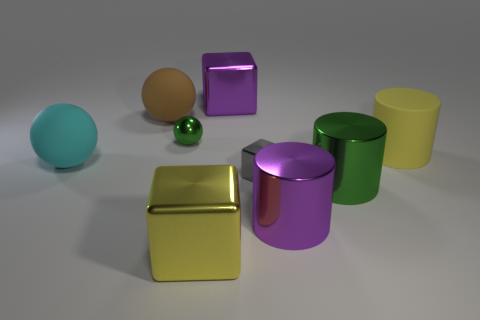What shape is the metal thing that is the same color as the small sphere?
Offer a terse response. Cylinder. What number of metallic things have the same color as the big matte cylinder?
Offer a terse response. 1. What is the size of the gray metallic block?
Provide a succinct answer. Small. There is a gray object; does it have the same size as the purple metallic object that is behind the cyan ball?
Offer a terse response. No. Is the number of big spheres that are to the right of the yellow matte cylinder the same as the number of tiny gray metal blocks on the right side of the large green cylinder?
Your answer should be compact. Yes. Is the large yellow object that is behind the big purple cylinder made of the same material as the large green object?
Make the answer very short. No. What is the color of the rubber object that is left of the purple cylinder and in front of the small green thing?
Provide a succinct answer. Cyan. There is a tiny object left of the big yellow block; what number of big green shiny objects are to the left of it?
Provide a succinct answer. 0. What material is the purple object that is the same shape as the large green metallic object?
Provide a succinct answer. Metal. What is the color of the tiny shiny sphere?
Make the answer very short. Green. 